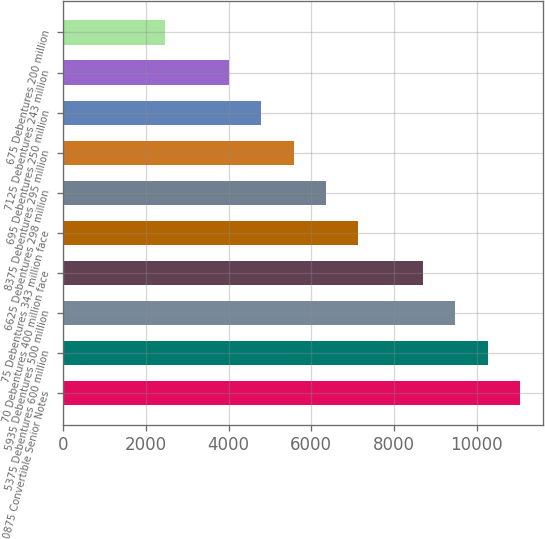Convert chart. <chart><loc_0><loc_0><loc_500><loc_500><bar_chart><fcel>0875 Convertible Senior Notes<fcel>5375 Debentures 600 million<fcel>5935 Debentures 500 million<fcel>70 Debentures 400 million face<fcel>75 Debentures 343 million face<fcel>6625 Debentures 298 million<fcel>8375 Debentures 295 million<fcel>695 Debentures 250 million<fcel>7125 Debentures 243 million<fcel>675 Debentures 200 million<nl><fcel>11050<fcel>10268<fcel>9486<fcel>8704<fcel>7140<fcel>6358<fcel>5576<fcel>4794<fcel>4012<fcel>2448<nl></chart> 